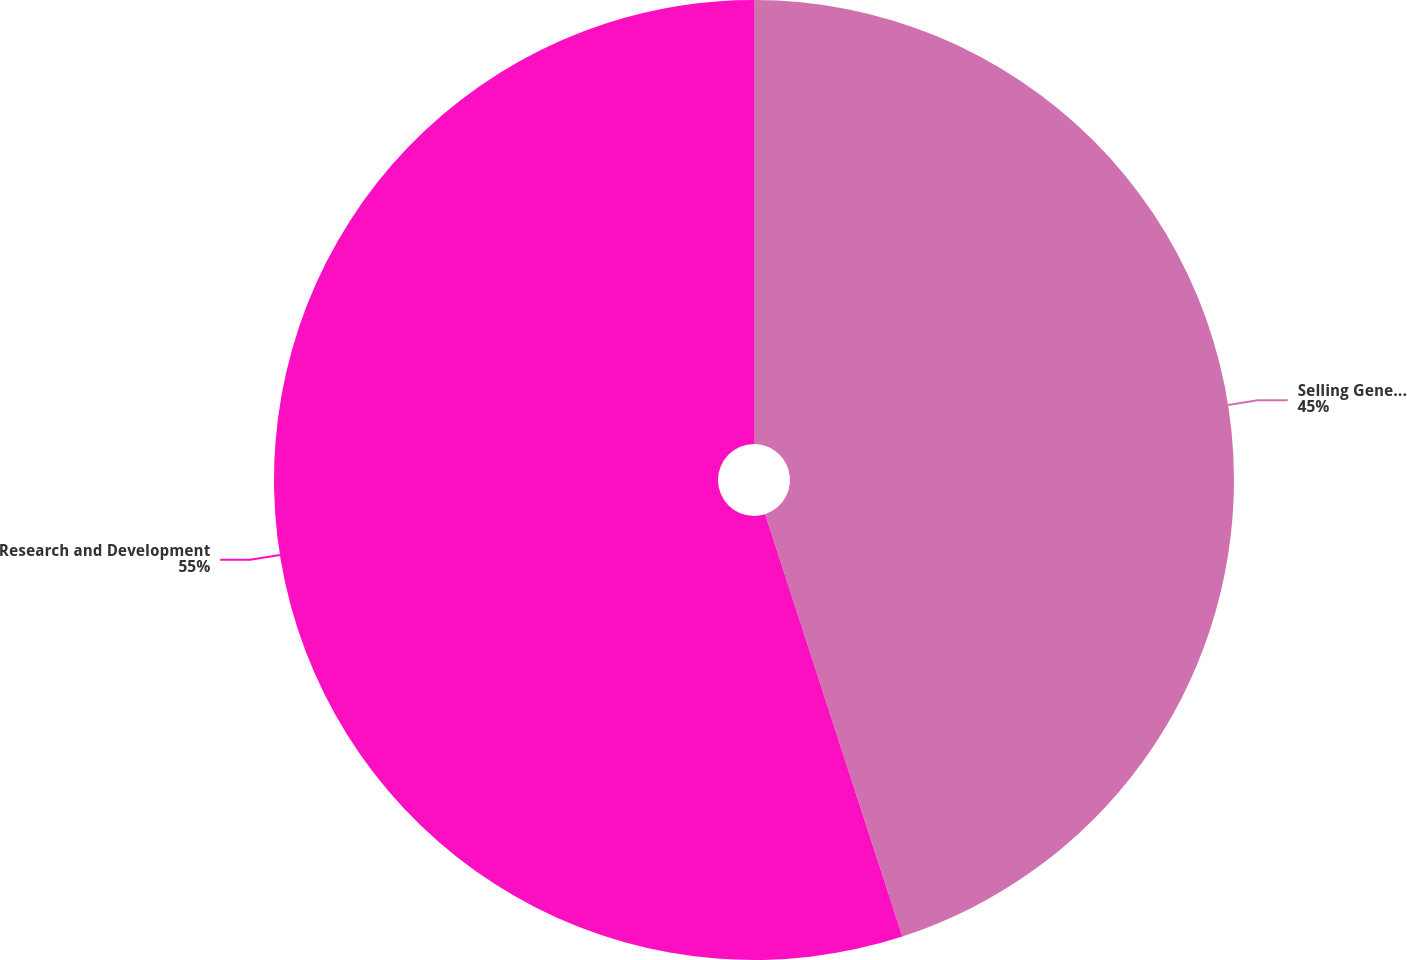<chart> <loc_0><loc_0><loc_500><loc_500><pie_chart><fcel>Selling General and<fcel>Research and Development<nl><fcel>45.0%<fcel>55.0%<nl></chart> 